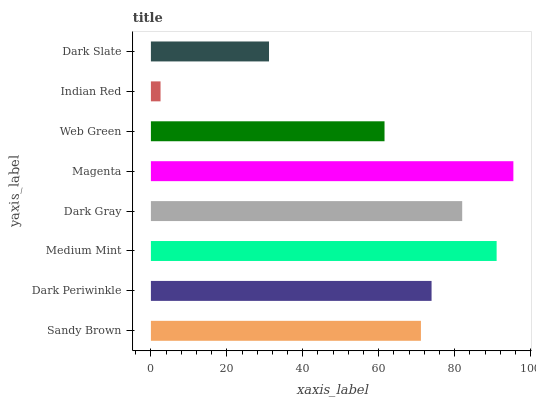Is Indian Red the minimum?
Answer yes or no. Yes. Is Magenta the maximum?
Answer yes or no. Yes. Is Dark Periwinkle the minimum?
Answer yes or no. No. Is Dark Periwinkle the maximum?
Answer yes or no. No. Is Dark Periwinkle greater than Sandy Brown?
Answer yes or no. Yes. Is Sandy Brown less than Dark Periwinkle?
Answer yes or no. Yes. Is Sandy Brown greater than Dark Periwinkle?
Answer yes or no. No. Is Dark Periwinkle less than Sandy Brown?
Answer yes or no. No. Is Dark Periwinkle the high median?
Answer yes or no. Yes. Is Sandy Brown the low median?
Answer yes or no. Yes. Is Dark Gray the high median?
Answer yes or no. No. Is Dark Gray the low median?
Answer yes or no. No. 